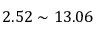<formula> <loc_0><loc_0><loc_500><loc_500>2 . 5 2 \sim 1 3 . 0 6</formula> 